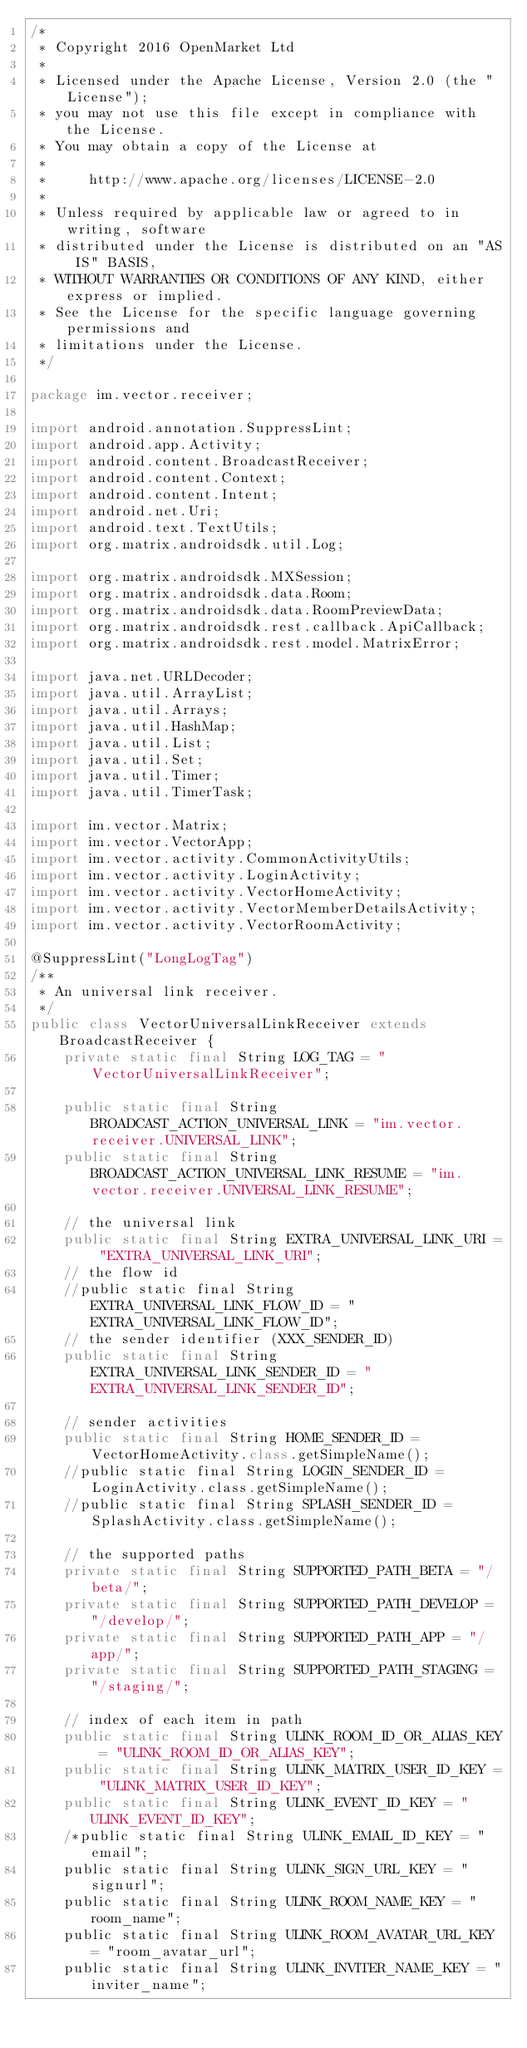<code> <loc_0><loc_0><loc_500><loc_500><_Java_>/*
 * Copyright 2016 OpenMarket Ltd
 *
 * Licensed under the Apache License, Version 2.0 (the "License");
 * you may not use this file except in compliance with the License.
 * You may obtain a copy of the License at
 *
 *     http://www.apache.org/licenses/LICENSE-2.0
 *
 * Unless required by applicable law or agreed to in writing, software
 * distributed under the License is distributed on an "AS IS" BASIS,
 * WITHOUT WARRANTIES OR CONDITIONS OF ANY KIND, either express or implied.
 * See the License for the specific language governing permissions and
 * limitations under the License.
 */

package im.vector.receiver;

import android.annotation.SuppressLint;
import android.app.Activity;
import android.content.BroadcastReceiver;
import android.content.Context;
import android.content.Intent;
import android.net.Uri;
import android.text.TextUtils;
import org.matrix.androidsdk.util.Log;

import org.matrix.androidsdk.MXSession;
import org.matrix.androidsdk.data.Room;
import org.matrix.androidsdk.data.RoomPreviewData;
import org.matrix.androidsdk.rest.callback.ApiCallback;
import org.matrix.androidsdk.rest.model.MatrixError;

import java.net.URLDecoder;
import java.util.ArrayList;
import java.util.Arrays;
import java.util.HashMap;
import java.util.List;
import java.util.Set;
import java.util.Timer;
import java.util.TimerTask;

import im.vector.Matrix;
import im.vector.VectorApp;
import im.vector.activity.CommonActivityUtils;
import im.vector.activity.LoginActivity;
import im.vector.activity.VectorHomeActivity;
import im.vector.activity.VectorMemberDetailsActivity;
import im.vector.activity.VectorRoomActivity;

@SuppressLint("LongLogTag")
/**
 * An universal link receiver.
 */
public class VectorUniversalLinkReceiver extends BroadcastReceiver {
    private static final String LOG_TAG = "VectorUniversalLinkReceiver";

    public static final String BROADCAST_ACTION_UNIVERSAL_LINK = "im.vector.receiver.UNIVERSAL_LINK";
    public static final String BROADCAST_ACTION_UNIVERSAL_LINK_RESUME = "im.vector.receiver.UNIVERSAL_LINK_RESUME";

    // the universal link
    public static final String EXTRA_UNIVERSAL_LINK_URI = "EXTRA_UNIVERSAL_LINK_URI";
    // the flow id
    //public static final String EXTRA_UNIVERSAL_LINK_FLOW_ID = "EXTRA_UNIVERSAL_LINK_FLOW_ID";
    // the sender identifier (XXX_SENDER_ID)
    public static final String EXTRA_UNIVERSAL_LINK_SENDER_ID = "EXTRA_UNIVERSAL_LINK_SENDER_ID";

    // sender activities
    public static final String HOME_SENDER_ID = VectorHomeActivity.class.getSimpleName();
    //public static final String LOGIN_SENDER_ID = LoginActivity.class.getSimpleName();
    //public static final String SPLASH_SENDER_ID = SplashActivity.class.getSimpleName();

    // the supported paths
    private static final String SUPPORTED_PATH_BETA = "/beta/";
    private static final String SUPPORTED_PATH_DEVELOP = "/develop/";
    private static final String SUPPORTED_PATH_APP = "/app/";
    private static final String SUPPORTED_PATH_STAGING = "/staging/";

    // index of each item in path
    public static final String ULINK_ROOM_ID_OR_ALIAS_KEY = "ULINK_ROOM_ID_OR_ALIAS_KEY";
    public static final String ULINK_MATRIX_USER_ID_KEY = "ULINK_MATRIX_USER_ID_KEY";
    public static final String ULINK_EVENT_ID_KEY = "ULINK_EVENT_ID_KEY";
    /*public static final String ULINK_EMAIL_ID_KEY = "email";
    public static final String ULINK_SIGN_URL_KEY = "signurl";
    public static final String ULINK_ROOM_NAME_KEY = "room_name";
    public static final String ULINK_ROOM_AVATAR_URL_KEY = "room_avatar_url";
    public static final String ULINK_INVITER_NAME_KEY = "inviter_name";</code> 